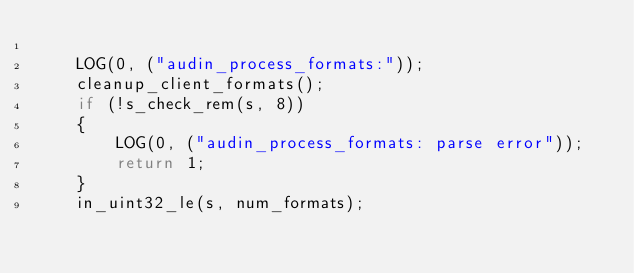Convert code to text. <code><loc_0><loc_0><loc_500><loc_500><_C_>
    LOG(0, ("audin_process_formats:"));
    cleanup_client_formats();
    if (!s_check_rem(s, 8))
    {
        LOG(0, ("audin_process_formats: parse error"));
        return 1;
    }
    in_uint32_le(s, num_formats);</code> 